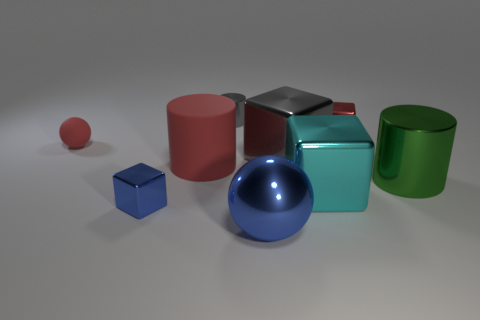Add 1 big objects. How many objects exist? 10 Subtract all red cubes. How many cubes are left? 3 Subtract all metallic cylinders. How many cylinders are left? 1 Subtract all cylinders. How many objects are left? 6 Subtract 2 blocks. How many blocks are left? 2 Subtract all yellow cylinders. Subtract all blue spheres. How many cylinders are left? 3 Subtract all blue cubes. How many gray cylinders are left? 1 Subtract all green matte balls. Subtract all cyan metallic things. How many objects are left? 8 Add 8 small gray things. How many small gray things are left? 9 Add 6 blue balls. How many blue balls exist? 7 